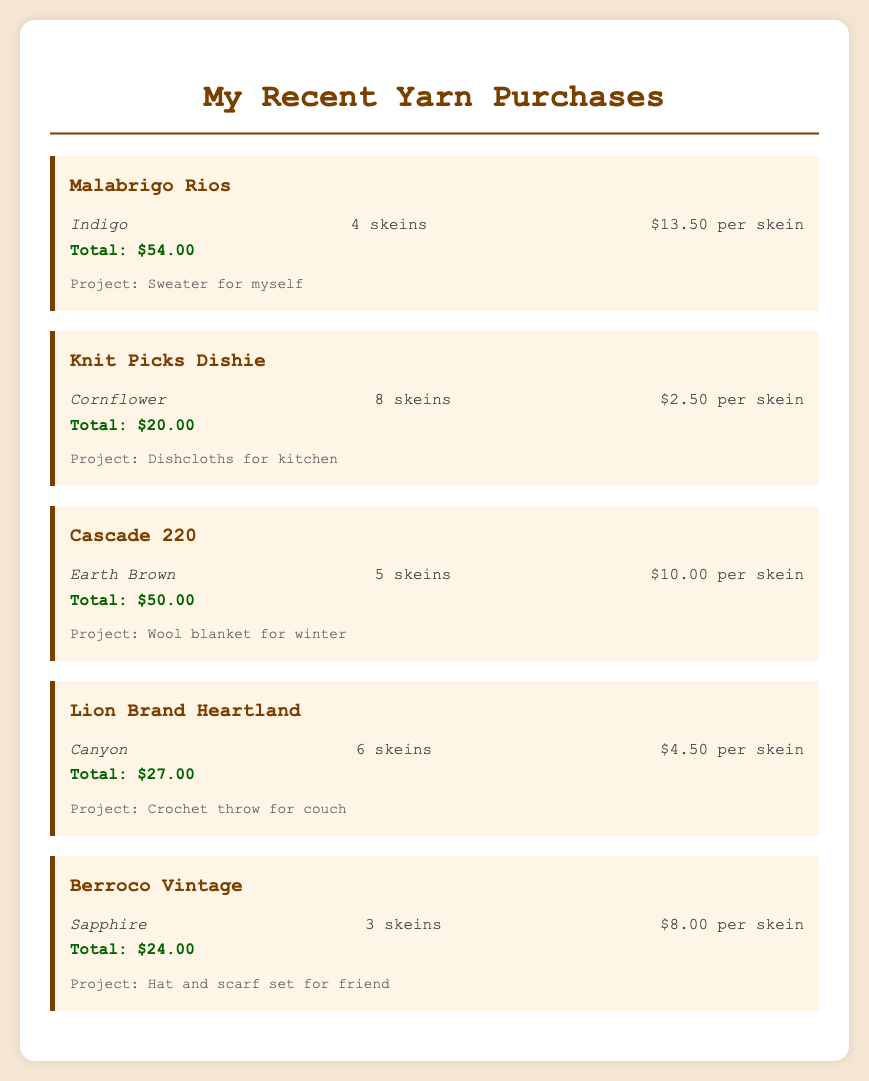What yarn was purchased for the sweater project? The yarn for the sweater project is Malabrigo Rios.
Answer: Malabrigo Rios How many skeins of Knit Picks Dishie were bought? The document states that 8 skeins of Knit Picks Dishie were purchased.
Answer: 8 skeins What is the total cost of the Cascade 220 yarn? The total cost for the Cascade 220 yarn is listed in the document.
Answer: $50.00 Which yarn is intended for a throw project? The yarn intended for a throw project is mentioned to be Lion Brand Heartland.
Answer: Lion Brand Heartland What is the color of the Berroco Vintage yarn? The color of the Berroco Vintage yarn is specified in the document.
Answer: Sapphire What is the price per skein of the Lion Brand Heartland yarn? The document provides the price per skein for Lion Brand Heartland yarn, which is $4.50.
Answer: $4.50 How many total projects are listed in the document? The document lists multiple projects in the yarn entries.
Answer: 5 projects What type of item is mentioned for the Knit Picks Dishie yarn? The intended use for the Knit Picks Dishie yarn is stated in the document.
Answer: Dishcloths for kitchen What is the color of the yarn purchased for the wool blanket project? The document specifies the color of the yarn for the wool blanket project.
Answer: Earth Brown 